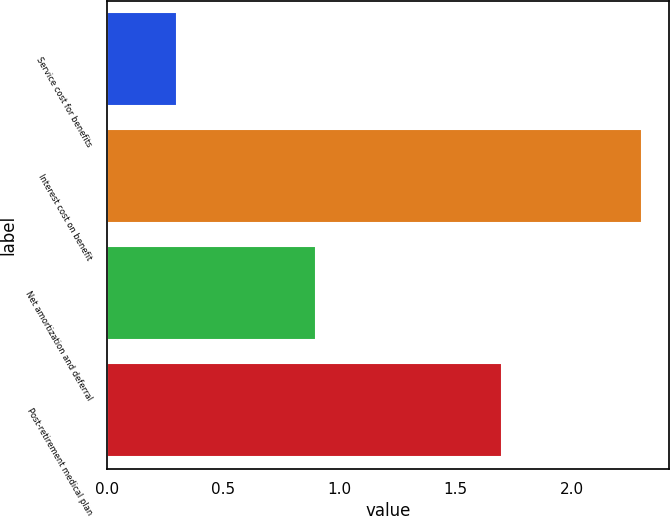Convert chart to OTSL. <chart><loc_0><loc_0><loc_500><loc_500><bar_chart><fcel>Service cost for benefits<fcel>Interest cost on benefit<fcel>Net amortization and deferral<fcel>Post-retirement medical plan<nl><fcel>0.3<fcel>2.3<fcel>0.9<fcel>1.7<nl></chart> 